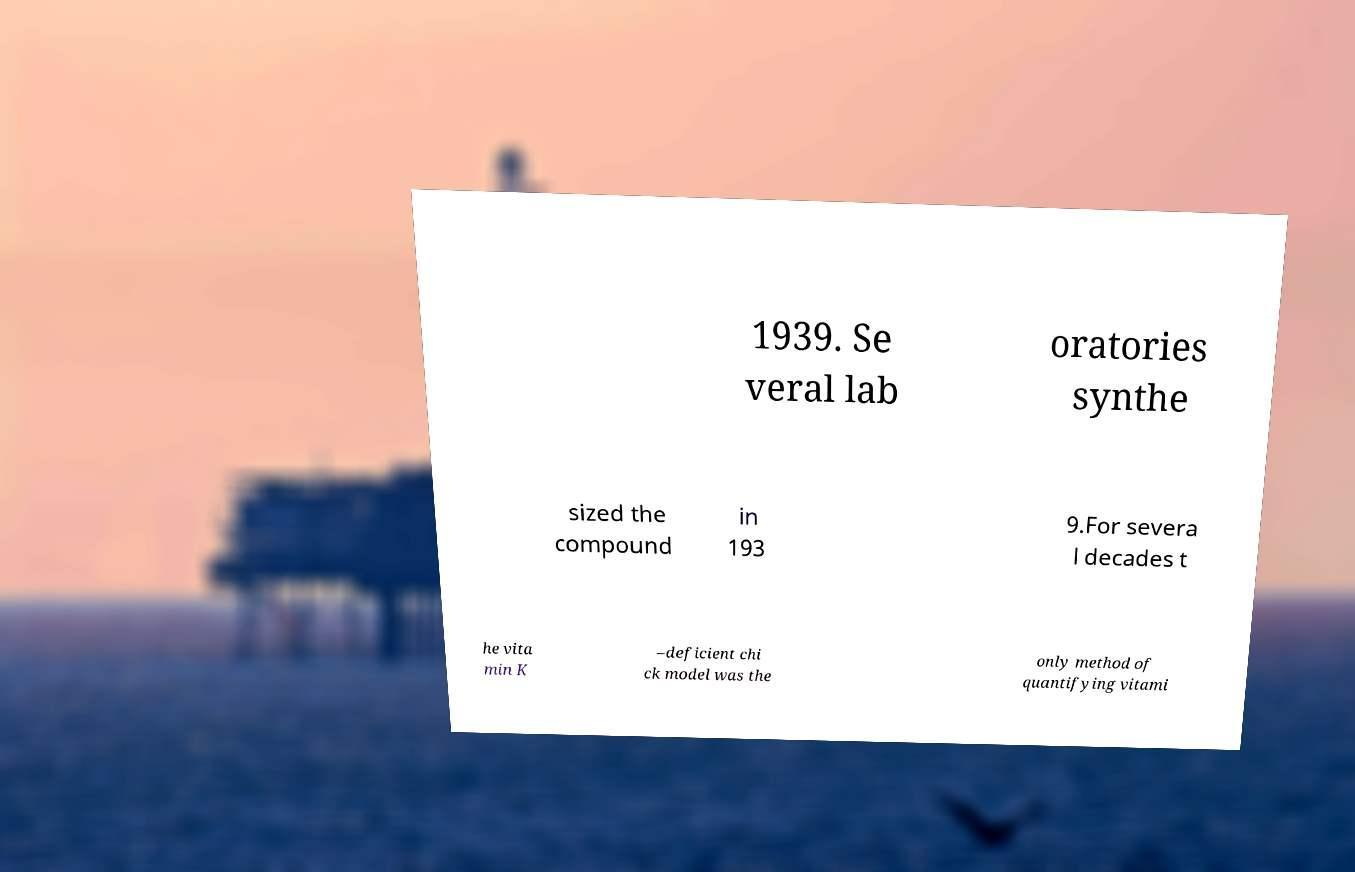There's text embedded in this image that I need extracted. Can you transcribe it verbatim? 1939. Se veral lab oratories synthe sized the compound in 193 9.For severa l decades t he vita min K –deficient chi ck model was the only method of quantifying vitami 